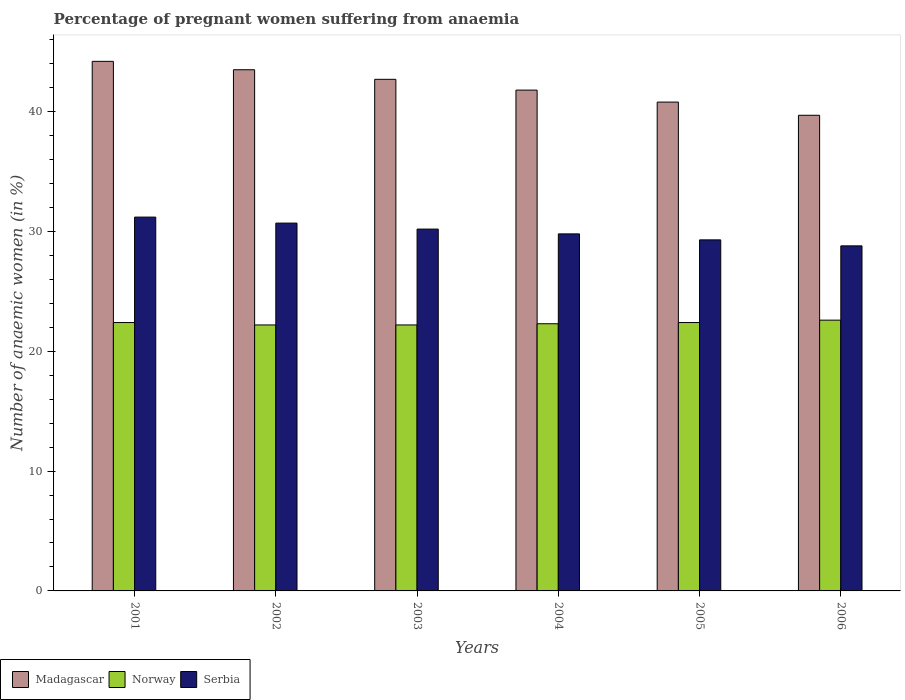How many different coloured bars are there?
Offer a terse response. 3. Are the number of bars per tick equal to the number of legend labels?
Make the answer very short. Yes. Are the number of bars on each tick of the X-axis equal?
Keep it short and to the point. Yes. What is the label of the 1st group of bars from the left?
Offer a very short reply. 2001. What is the number of anaemic women in Serbia in 2002?
Your response must be concise. 30.7. Across all years, what is the maximum number of anaemic women in Norway?
Keep it short and to the point. 22.6. Across all years, what is the minimum number of anaemic women in Madagascar?
Your answer should be compact. 39.7. In which year was the number of anaemic women in Serbia minimum?
Give a very brief answer. 2006. What is the total number of anaemic women in Norway in the graph?
Offer a very short reply. 134.1. What is the difference between the number of anaemic women in Madagascar in 2002 and that in 2006?
Offer a terse response. 3.8. What is the difference between the number of anaemic women in Norway in 2003 and the number of anaemic women in Madagascar in 2002?
Your answer should be very brief. -21.3. In the year 2006, what is the difference between the number of anaemic women in Norway and number of anaemic women in Serbia?
Give a very brief answer. -6.2. What is the ratio of the number of anaemic women in Serbia in 2001 to that in 2004?
Make the answer very short. 1.05. Is the number of anaemic women in Serbia in 2001 less than that in 2004?
Offer a very short reply. No. What is the difference between the highest and the second highest number of anaemic women in Norway?
Make the answer very short. 0.2. What is the difference between the highest and the lowest number of anaemic women in Serbia?
Offer a terse response. 2.4. In how many years, is the number of anaemic women in Serbia greater than the average number of anaemic women in Serbia taken over all years?
Your answer should be very brief. 3. Is the sum of the number of anaemic women in Madagascar in 2002 and 2003 greater than the maximum number of anaemic women in Norway across all years?
Give a very brief answer. Yes. What does the 3rd bar from the left in 2001 represents?
Provide a short and direct response. Serbia. How many bars are there?
Your answer should be compact. 18. Are all the bars in the graph horizontal?
Offer a terse response. No. How many years are there in the graph?
Your answer should be compact. 6. What is the difference between two consecutive major ticks on the Y-axis?
Offer a very short reply. 10. Are the values on the major ticks of Y-axis written in scientific E-notation?
Give a very brief answer. No. Does the graph contain any zero values?
Give a very brief answer. No. Does the graph contain grids?
Your response must be concise. No. Where does the legend appear in the graph?
Make the answer very short. Bottom left. How many legend labels are there?
Provide a succinct answer. 3. How are the legend labels stacked?
Your answer should be compact. Horizontal. What is the title of the graph?
Offer a terse response. Percentage of pregnant women suffering from anaemia. Does "Venezuela" appear as one of the legend labels in the graph?
Ensure brevity in your answer.  No. What is the label or title of the X-axis?
Provide a succinct answer. Years. What is the label or title of the Y-axis?
Keep it short and to the point. Number of anaemic women (in %). What is the Number of anaemic women (in %) in Madagascar in 2001?
Make the answer very short. 44.2. What is the Number of anaemic women (in %) of Norway in 2001?
Your answer should be very brief. 22.4. What is the Number of anaemic women (in %) of Serbia in 2001?
Offer a very short reply. 31.2. What is the Number of anaemic women (in %) of Madagascar in 2002?
Provide a succinct answer. 43.5. What is the Number of anaemic women (in %) of Norway in 2002?
Make the answer very short. 22.2. What is the Number of anaemic women (in %) in Serbia in 2002?
Make the answer very short. 30.7. What is the Number of anaemic women (in %) in Madagascar in 2003?
Your answer should be very brief. 42.7. What is the Number of anaemic women (in %) of Norway in 2003?
Provide a succinct answer. 22.2. What is the Number of anaemic women (in %) in Serbia in 2003?
Your answer should be compact. 30.2. What is the Number of anaemic women (in %) in Madagascar in 2004?
Your answer should be very brief. 41.8. What is the Number of anaemic women (in %) in Norway in 2004?
Give a very brief answer. 22.3. What is the Number of anaemic women (in %) of Serbia in 2004?
Provide a short and direct response. 29.8. What is the Number of anaemic women (in %) in Madagascar in 2005?
Offer a terse response. 40.8. What is the Number of anaemic women (in %) in Norway in 2005?
Provide a succinct answer. 22.4. What is the Number of anaemic women (in %) in Serbia in 2005?
Make the answer very short. 29.3. What is the Number of anaemic women (in %) in Madagascar in 2006?
Give a very brief answer. 39.7. What is the Number of anaemic women (in %) in Norway in 2006?
Your answer should be compact. 22.6. What is the Number of anaemic women (in %) of Serbia in 2006?
Offer a terse response. 28.8. Across all years, what is the maximum Number of anaemic women (in %) of Madagascar?
Provide a succinct answer. 44.2. Across all years, what is the maximum Number of anaemic women (in %) in Norway?
Make the answer very short. 22.6. Across all years, what is the maximum Number of anaemic women (in %) of Serbia?
Offer a terse response. 31.2. Across all years, what is the minimum Number of anaemic women (in %) in Madagascar?
Provide a short and direct response. 39.7. Across all years, what is the minimum Number of anaemic women (in %) of Serbia?
Provide a short and direct response. 28.8. What is the total Number of anaemic women (in %) of Madagascar in the graph?
Keep it short and to the point. 252.7. What is the total Number of anaemic women (in %) in Norway in the graph?
Make the answer very short. 134.1. What is the total Number of anaemic women (in %) in Serbia in the graph?
Offer a very short reply. 180. What is the difference between the Number of anaemic women (in %) in Serbia in 2001 and that in 2002?
Your response must be concise. 0.5. What is the difference between the Number of anaemic women (in %) of Madagascar in 2001 and that in 2003?
Ensure brevity in your answer.  1.5. What is the difference between the Number of anaemic women (in %) of Norway in 2001 and that in 2003?
Make the answer very short. 0.2. What is the difference between the Number of anaemic women (in %) in Madagascar in 2001 and that in 2004?
Offer a terse response. 2.4. What is the difference between the Number of anaemic women (in %) in Norway in 2001 and that in 2005?
Provide a succinct answer. 0. What is the difference between the Number of anaemic women (in %) of Serbia in 2001 and that in 2005?
Your answer should be compact. 1.9. What is the difference between the Number of anaemic women (in %) in Madagascar in 2001 and that in 2006?
Keep it short and to the point. 4.5. What is the difference between the Number of anaemic women (in %) in Norway in 2001 and that in 2006?
Your answer should be very brief. -0.2. What is the difference between the Number of anaemic women (in %) in Norway in 2002 and that in 2003?
Provide a short and direct response. 0. What is the difference between the Number of anaemic women (in %) of Madagascar in 2002 and that in 2004?
Ensure brevity in your answer.  1.7. What is the difference between the Number of anaemic women (in %) of Norway in 2002 and that in 2004?
Offer a terse response. -0.1. What is the difference between the Number of anaemic women (in %) in Serbia in 2002 and that in 2004?
Offer a very short reply. 0.9. What is the difference between the Number of anaemic women (in %) of Norway in 2002 and that in 2005?
Offer a very short reply. -0.2. What is the difference between the Number of anaemic women (in %) in Serbia in 2002 and that in 2005?
Make the answer very short. 1.4. What is the difference between the Number of anaemic women (in %) of Madagascar in 2002 and that in 2006?
Ensure brevity in your answer.  3.8. What is the difference between the Number of anaemic women (in %) of Norway in 2002 and that in 2006?
Offer a terse response. -0.4. What is the difference between the Number of anaemic women (in %) in Norway in 2003 and that in 2004?
Make the answer very short. -0.1. What is the difference between the Number of anaemic women (in %) in Madagascar in 2003 and that in 2005?
Offer a very short reply. 1.9. What is the difference between the Number of anaemic women (in %) of Norway in 2003 and that in 2005?
Offer a very short reply. -0.2. What is the difference between the Number of anaemic women (in %) of Serbia in 2003 and that in 2005?
Provide a short and direct response. 0.9. What is the difference between the Number of anaemic women (in %) in Norway in 2003 and that in 2006?
Provide a succinct answer. -0.4. What is the difference between the Number of anaemic women (in %) of Serbia in 2003 and that in 2006?
Offer a very short reply. 1.4. What is the difference between the Number of anaemic women (in %) in Madagascar in 2004 and that in 2005?
Your response must be concise. 1. What is the difference between the Number of anaemic women (in %) in Norway in 2004 and that in 2005?
Give a very brief answer. -0.1. What is the difference between the Number of anaemic women (in %) in Madagascar in 2004 and that in 2006?
Offer a terse response. 2.1. What is the difference between the Number of anaemic women (in %) in Serbia in 2004 and that in 2006?
Give a very brief answer. 1. What is the difference between the Number of anaemic women (in %) of Norway in 2005 and that in 2006?
Provide a short and direct response. -0.2. What is the difference between the Number of anaemic women (in %) of Serbia in 2005 and that in 2006?
Provide a short and direct response. 0.5. What is the difference between the Number of anaemic women (in %) of Madagascar in 2001 and the Number of anaemic women (in %) of Serbia in 2002?
Your answer should be compact. 13.5. What is the difference between the Number of anaemic women (in %) in Norway in 2001 and the Number of anaemic women (in %) in Serbia in 2002?
Make the answer very short. -8.3. What is the difference between the Number of anaemic women (in %) of Madagascar in 2001 and the Number of anaemic women (in %) of Norway in 2003?
Offer a very short reply. 22. What is the difference between the Number of anaemic women (in %) of Madagascar in 2001 and the Number of anaemic women (in %) of Serbia in 2003?
Ensure brevity in your answer.  14. What is the difference between the Number of anaemic women (in %) in Norway in 2001 and the Number of anaemic women (in %) in Serbia in 2003?
Make the answer very short. -7.8. What is the difference between the Number of anaemic women (in %) in Madagascar in 2001 and the Number of anaemic women (in %) in Norway in 2004?
Your answer should be very brief. 21.9. What is the difference between the Number of anaemic women (in %) in Madagascar in 2001 and the Number of anaemic women (in %) in Serbia in 2004?
Make the answer very short. 14.4. What is the difference between the Number of anaemic women (in %) of Norway in 2001 and the Number of anaemic women (in %) of Serbia in 2004?
Offer a terse response. -7.4. What is the difference between the Number of anaemic women (in %) in Madagascar in 2001 and the Number of anaemic women (in %) in Norway in 2005?
Your answer should be very brief. 21.8. What is the difference between the Number of anaemic women (in %) in Madagascar in 2001 and the Number of anaemic women (in %) in Serbia in 2005?
Offer a terse response. 14.9. What is the difference between the Number of anaemic women (in %) in Madagascar in 2001 and the Number of anaemic women (in %) in Norway in 2006?
Your answer should be compact. 21.6. What is the difference between the Number of anaemic women (in %) of Norway in 2001 and the Number of anaemic women (in %) of Serbia in 2006?
Your response must be concise. -6.4. What is the difference between the Number of anaemic women (in %) of Madagascar in 2002 and the Number of anaemic women (in %) of Norway in 2003?
Ensure brevity in your answer.  21.3. What is the difference between the Number of anaemic women (in %) of Madagascar in 2002 and the Number of anaemic women (in %) of Norway in 2004?
Your answer should be compact. 21.2. What is the difference between the Number of anaemic women (in %) in Madagascar in 2002 and the Number of anaemic women (in %) in Serbia in 2004?
Make the answer very short. 13.7. What is the difference between the Number of anaemic women (in %) in Madagascar in 2002 and the Number of anaemic women (in %) in Norway in 2005?
Give a very brief answer. 21.1. What is the difference between the Number of anaemic women (in %) in Madagascar in 2002 and the Number of anaemic women (in %) in Serbia in 2005?
Provide a succinct answer. 14.2. What is the difference between the Number of anaemic women (in %) in Norway in 2002 and the Number of anaemic women (in %) in Serbia in 2005?
Offer a very short reply. -7.1. What is the difference between the Number of anaemic women (in %) of Madagascar in 2002 and the Number of anaemic women (in %) of Norway in 2006?
Make the answer very short. 20.9. What is the difference between the Number of anaemic women (in %) in Madagascar in 2002 and the Number of anaemic women (in %) in Serbia in 2006?
Provide a succinct answer. 14.7. What is the difference between the Number of anaemic women (in %) of Norway in 2002 and the Number of anaemic women (in %) of Serbia in 2006?
Offer a terse response. -6.6. What is the difference between the Number of anaemic women (in %) of Madagascar in 2003 and the Number of anaemic women (in %) of Norway in 2004?
Keep it short and to the point. 20.4. What is the difference between the Number of anaemic women (in %) of Norway in 2003 and the Number of anaemic women (in %) of Serbia in 2004?
Keep it short and to the point. -7.6. What is the difference between the Number of anaemic women (in %) in Madagascar in 2003 and the Number of anaemic women (in %) in Norway in 2005?
Provide a short and direct response. 20.3. What is the difference between the Number of anaemic women (in %) in Madagascar in 2003 and the Number of anaemic women (in %) in Serbia in 2005?
Offer a very short reply. 13.4. What is the difference between the Number of anaemic women (in %) of Madagascar in 2003 and the Number of anaemic women (in %) of Norway in 2006?
Make the answer very short. 20.1. What is the difference between the Number of anaemic women (in %) of Madagascar in 2003 and the Number of anaemic women (in %) of Serbia in 2006?
Your answer should be compact. 13.9. What is the difference between the Number of anaemic women (in %) of Norway in 2004 and the Number of anaemic women (in %) of Serbia in 2005?
Make the answer very short. -7. What is the difference between the Number of anaemic women (in %) of Madagascar in 2004 and the Number of anaemic women (in %) of Serbia in 2006?
Offer a very short reply. 13. What is the difference between the Number of anaemic women (in %) in Norway in 2004 and the Number of anaemic women (in %) in Serbia in 2006?
Provide a short and direct response. -6.5. What is the difference between the Number of anaemic women (in %) in Madagascar in 2005 and the Number of anaemic women (in %) in Norway in 2006?
Your response must be concise. 18.2. What is the average Number of anaemic women (in %) in Madagascar per year?
Your answer should be compact. 42.12. What is the average Number of anaemic women (in %) in Norway per year?
Offer a terse response. 22.35. In the year 2001, what is the difference between the Number of anaemic women (in %) of Madagascar and Number of anaemic women (in %) of Norway?
Your answer should be very brief. 21.8. In the year 2001, what is the difference between the Number of anaemic women (in %) of Madagascar and Number of anaemic women (in %) of Serbia?
Provide a short and direct response. 13. In the year 2002, what is the difference between the Number of anaemic women (in %) in Madagascar and Number of anaemic women (in %) in Norway?
Your response must be concise. 21.3. In the year 2003, what is the difference between the Number of anaemic women (in %) in Madagascar and Number of anaemic women (in %) in Serbia?
Your answer should be compact. 12.5. In the year 2004, what is the difference between the Number of anaemic women (in %) of Madagascar and Number of anaemic women (in %) of Serbia?
Your answer should be compact. 12. In the year 2004, what is the difference between the Number of anaemic women (in %) of Norway and Number of anaemic women (in %) of Serbia?
Keep it short and to the point. -7.5. In the year 2006, what is the difference between the Number of anaemic women (in %) of Madagascar and Number of anaemic women (in %) of Serbia?
Provide a short and direct response. 10.9. What is the ratio of the Number of anaemic women (in %) of Madagascar in 2001 to that in 2002?
Provide a succinct answer. 1.02. What is the ratio of the Number of anaemic women (in %) in Norway in 2001 to that in 2002?
Offer a very short reply. 1.01. What is the ratio of the Number of anaemic women (in %) of Serbia in 2001 to that in 2002?
Provide a short and direct response. 1.02. What is the ratio of the Number of anaemic women (in %) in Madagascar in 2001 to that in 2003?
Give a very brief answer. 1.04. What is the ratio of the Number of anaemic women (in %) of Serbia in 2001 to that in 2003?
Provide a short and direct response. 1.03. What is the ratio of the Number of anaemic women (in %) of Madagascar in 2001 to that in 2004?
Offer a very short reply. 1.06. What is the ratio of the Number of anaemic women (in %) in Serbia in 2001 to that in 2004?
Give a very brief answer. 1.05. What is the ratio of the Number of anaemic women (in %) of Madagascar in 2001 to that in 2005?
Your answer should be compact. 1.08. What is the ratio of the Number of anaemic women (in %) of Serbia in 2001 to that in 2005?
Give a very brief answer. 1.06. What is the ratio of the Number of anaemic women (in %) of Madagascar in 2001 to that in 2006?
Your answer should be very brief. 1.11. What is the ratio of the Number of anaemic women (in %) of Norway in 2001 to that in 2006?
Your answer should be very brief. 0.99. What is the ratio of the Number of anaemic women (in %) in Madagascar in 2002 to that in 2003?
Your response must be concise. 1.02. What is the ratio of the Number of anaemic women (in %) of Norway in 2002 to that in 2003?
Make the answer very short. 1. What is the ratio of the Number of anaemic women (in %) of Serbia in 2002 to that in 2003?
Offer a very short reply. 1.02. What is the ratio of the Number of anaemic women (in %) of Madagascar in 2002 to that in 2004?
Your answer should be very brief. 1.04. What is the ratio of the Number of anaemic women (in %) in Norway in 2002 to that in 2004?
Ensure brevity in your answer.  1. What is the ratio of the Number of anaemic women (in %) of Serbia in 2002 to that in 2004?
Make the answer very short. 1.03. What is the ratio of the Number of anaemic women (in %) in Madagascar in 2002 to that in 2005?
Provide a succinct answer. 1.07. What is the ratio of the Number of anaemic women (in %) of Serbia in 2002 to that in 2005?
Offer a terse response. 1.05. What is the ratio of the Number of anaemic women (in %) in Madagascar in 2002 to that in 2006?
Offer a very short reply. 1.1. What is the ratio of the Number of anaemic women (in %) in Norway in 2002 to that in 2006?
Offer a very short reply. 0.98. What is the ratio of the Number of anaemic women (in %) in Serbia in 2002 to that in 2006?
Provide a succinct answer. 1.07. What is the ratio of the Number of anaemic women (in %) in Madagascar in 2003 to that in 2004?
Keep it short and to the point. 1.02. What is the ratio of the Number of anaemic women (in %) of Serbia in 2003 to that in 2004?
Your answer should be compact. 1.01. What is the ratio of the Number of anaemic women (in %) of Madagascar in 2003 to that in 2005?
Provide a succinct answer. 1.05. What is the ratio of the Number of anaemic women (in %) in Norway in 2003 to that in 2005?
Offer a very short reply. 0.99. What is the ratio of the Number of anaemic women (in %) of Serbia in 2003 to that in 2005?
Provide a short and direct response. 1.03. What is the ratio of the Number of anaemic women (in %) in Madagascar in 2003 to that in 2006?
Your response must be concise. 1.08. What is the ratio of the Number of anaemic women (in %) in Norway in 2003 to that in 2006?
Ensure brevity in your answer.  0.98. What is the ratio of the Number of anaemic women (in %) of Serbia in 2003 to that in 2006?
Offer a terse response. 1.05. What is the ratio of the Number of anaemic women (in %) in Madagascar in 2004 to that in 2005?
Keep it short and to the point. 1.02. What is the ratio of the Number of anaemic women (in %) of Norway in 2004 to that in 2005?
Make the answer very short. 1. What is the ratio of the Number of anaemic women (in %) in Serbia in 2004 to that in 2005?
Give a very brief answer. 1.02. What is the ratio of the Number of anaemic women (in %) in Madagascar in 2004 to that in 2006?
Your response must be concise. 1.05. What is the ratio of the Number of anaemic women (in %) in Norway in 2004 to that in 2006?
Offer a very short reply. 0.99. What is the ratio of the Number of anaemic women (in %) of Serbia in 2004 to that in 2006?
Your answer should be very brief. 1.03. What is the ratio of the Number of anaemic women (in %) in Madagascar in 2005 to that in 2006?
Give a very brief answer. 1.03. What is the ratio of the Number of anaemic women (in %) in Serbia in 2005 to that in 2006?
Offer a very short reply. 1.02. What is the difference between the highest and the second highest Number of anaemic women (in %) in Madagascar?
Your answer should be very brief. 0.7. What is the difference between the highest and the second highest Number of anaemic women (in %) in Norway?
Your response must be concise. 0.2. What is the difference between the highest and the second highest Number of anaemic women (in %) in Serbia?
Your response must be concise. 0.5. What is the difference between the highest and the lowest Number of anaemic women (in %) in Norway?
Provide a succinct answer. 0.4. 